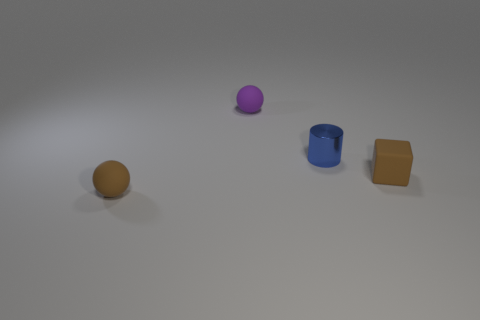Is there anything else that is the same material as the blue object?
Your answer should be compact. No. There is a small matte thing that is the same color as the rubber block; what is its shape?
Ensure brevity in your answer.  Sphere. What number of other objects are the same color as the cube?
Keep it short and to the point. 1. There is a tiny ball that is in front of the small purple rubber ball; is it the same color as the small cube?
Ensure brevity in your answer.  Yes. Does the sphere that is behind the brown matte ball have the same material as the blue cylinder?
Provide a succinct answer. No. Is there a small cube?
Your response must be concise. Yes. What color is the other ball that is made of the same material as the small brown sphere?
Provide a succinct answer. Purple. There is a rubber sphere that is behind the brown matte object that is behind the brown thing that is in front of the cube; what is its color?
Keep it short and to the point. Purple. There is a blue shiny object; is it the same size as the ball that is in front of the blue shiny thing?
Your response must be concise. Yes. What number of things are either small brown things that are to the right of the small cylinder or small matte objects that are left of the block?
Offer a terse response. 3. 